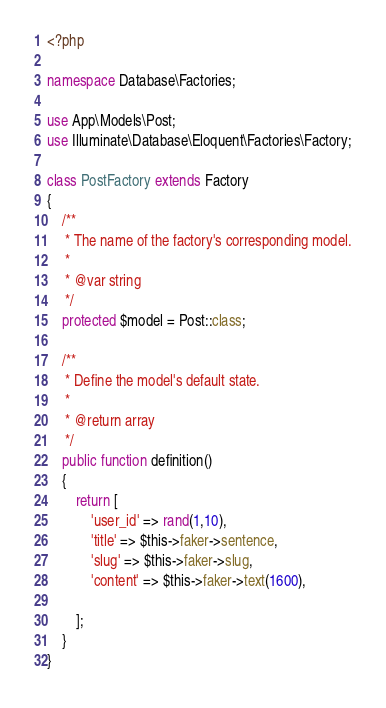Convert code to text. <code><loc_0><loc_0><loc_500><loc_500><_PHP_><?php

namespace Database\Factories;

use App\Models\Post;
use Illuminate\Database\Eloquent\Factories\Factory;

class PostFactory extends Factory
{
    /**
     * The name of the factory's corresponding model.
     *
     * @var string
     */
    protected $model = Post::class;

    /**
     * Define the model's default state.
     *
     * @return array
     */
    public function definition()
    {
        return [
            'user_id' => rand(1,10),
            'title' => $this->faker->sentence,
            'slug' => $this->faker->slug,
            'content' => $this->faker->text(1600),

        ];
    }
}
</code> 